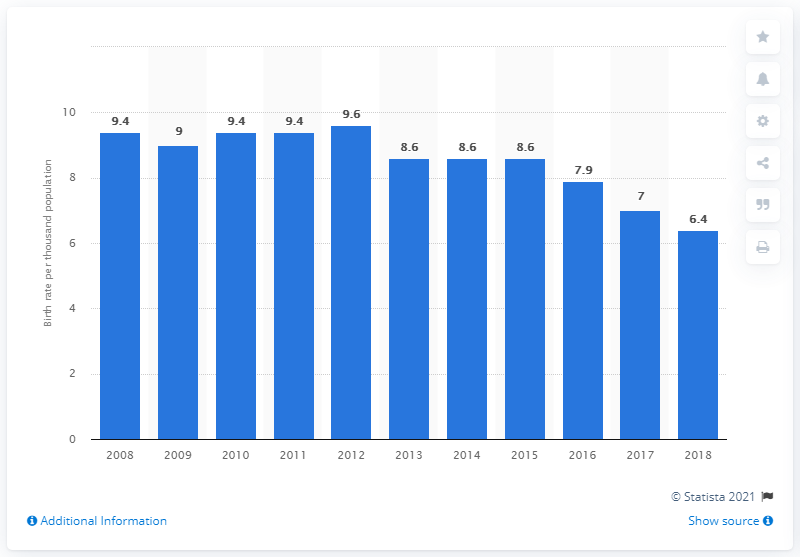Mention a couple of crucial points in this snapshot. In 2018, the crude birth rate in South Korea was 6.4. 